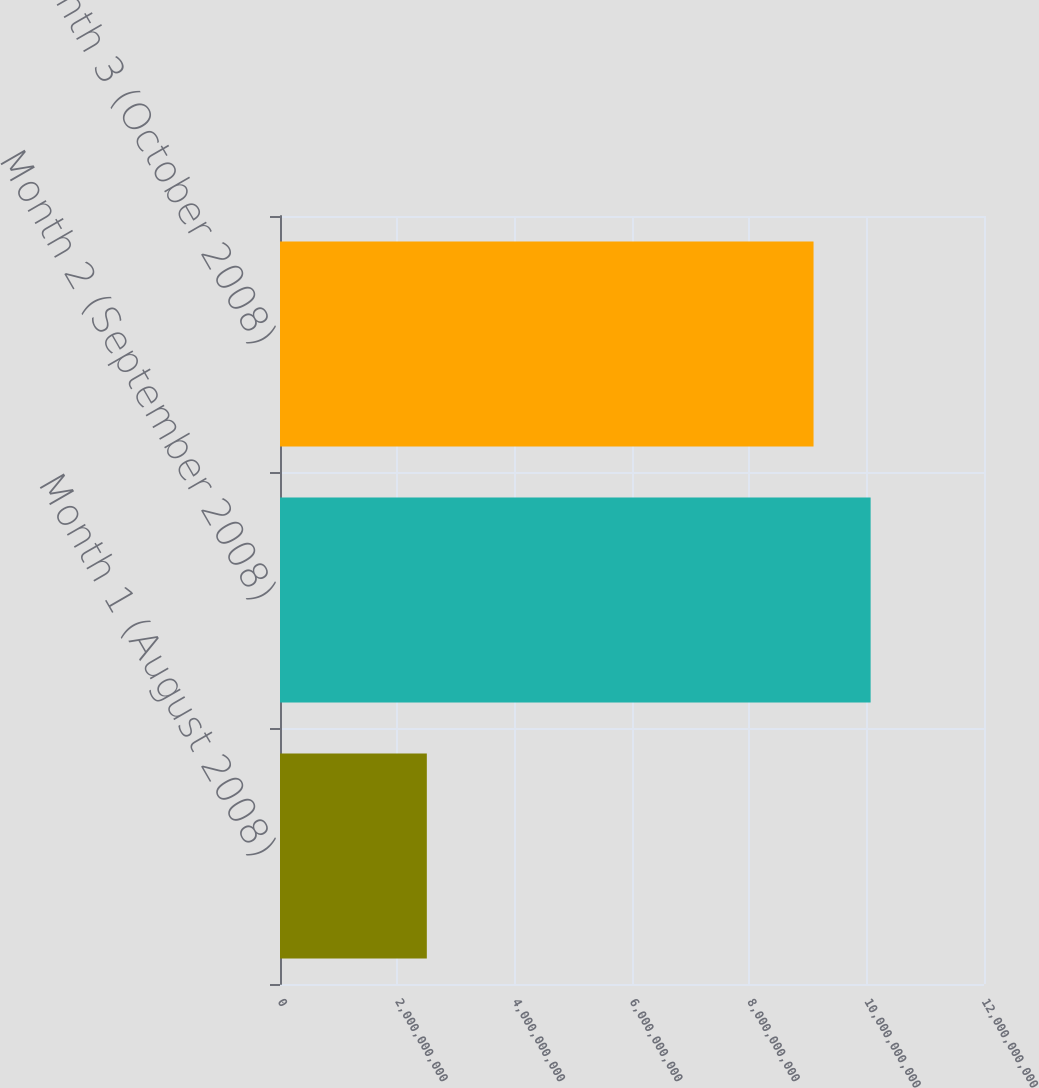<chart> <loc_0><loc_0><loc_500><loc_500><bar_chart><fcel>Month 1 (August 2008)<fcel>Month 2 (September 2008)<fcel>Month 3 (October 2008)<nl><fcel>2.50281e+09<fcel>1.00675e+10<fcel>9.09442e+09<nl></chart> 